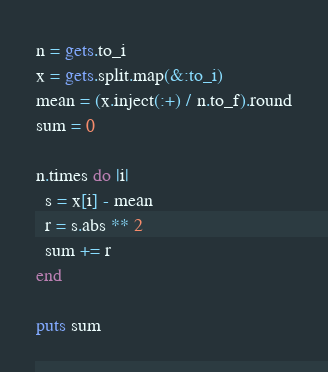Convert code to text. <code><loc_0><loc_0><loc_500><loc_500><_Ruby_>n = gets.to_i
x = gets.split.map(&:to_i)
mean = (x.inject(:+) / n.to_f).round
sum = 0

n.times do |i|
  s = x[i] - mean
  r = s.abs ** 2
  sum += r
end

puts sum
</code> 